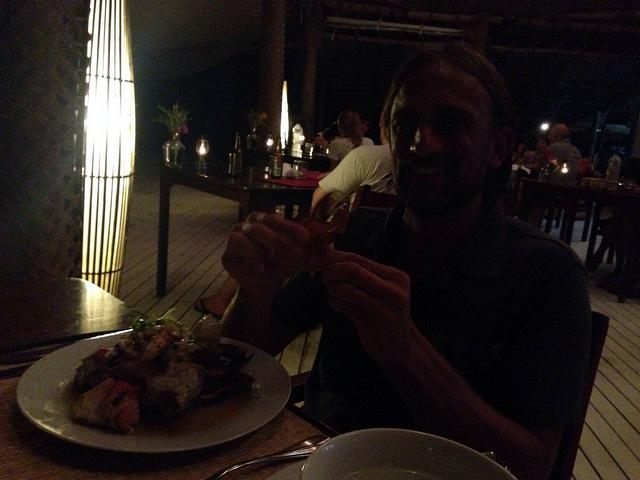What kind of food is the man consuming? Please explain your reasoning. seafood. The food is seafood. 